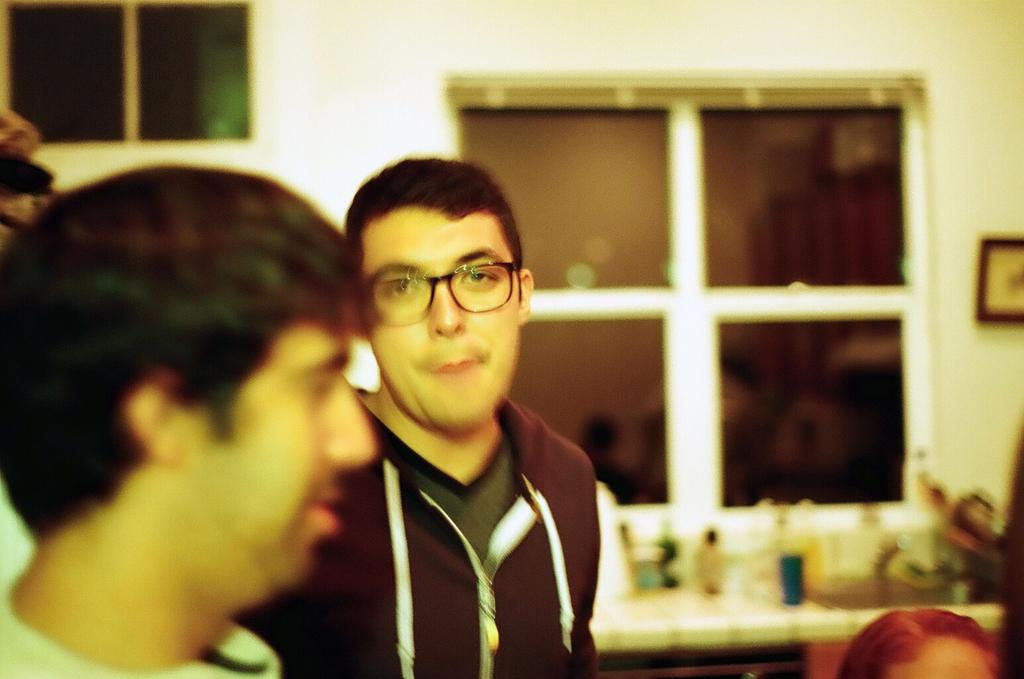Who or what can be seen in the image? There are people in the image. What is the main piece of furniture in the image? There is a table in the image. What is placed on the table? There are objects on the table. What can be seen in the background of the image? There are windows visible in the background. What is hanging on the wall in the background? There is a photo frame on the wall in the background. Can you see any hills in the image? There are no hills visible in the image. What type of farm can be seen in the background of the image? There is no farm present in the image. 